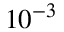Convert formula to latex. <formula><loc_0><loc_0><loc_500><loc_500>1 0 ^ { - 3 }</formula> 